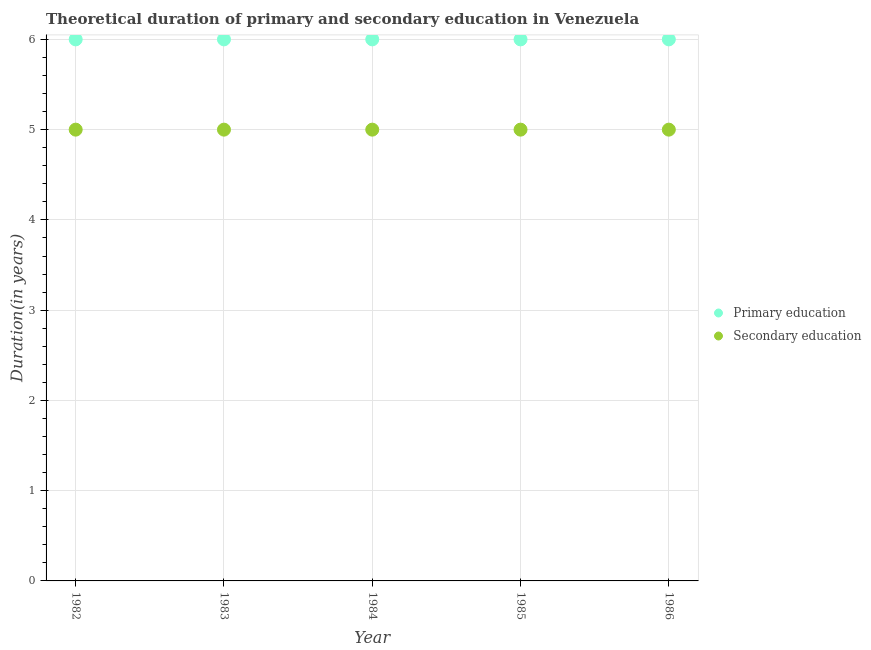How many different coloured dotlines are there?
Make the answer very short. 2. Is the number of dotlines equal to the number of legend labels?
Provide a short and direct response. Yes. Across all years, what is the minimum duration of secondary education?
Give a very brief answer. 5. What is the total duration of primary education in the graph?
Your answer should be compact. 30. What is the difference between the duration of primary education in 1983 and that in 1985?
Offer a terse response. 0. What is the difference between the duration of secondary education in 1986 and the duration of primary education in 1984?
Provide a short and direct response. -1. What is the average duration of secondary education per year?
Give a very brief answer. 5. In the year 1985, what is the difference between the duration of primary education and duration of secondary education?
Your response must be concise. 1. In how many years, is the duration of primary education greater than 3.8 years?
Your answer should be compact. 5. Is the duration of secondary education in 1983 less than that in 1984?
Offer a very short reply. No. Is the difference between the duration of primary education in 1982 and 1984 greater than the difference between the duration of secondary education in 1982 and 1984?
Offer a terse response. No. What is the difference between the highest and the second highest duration of primary education?
Provide a short and direct response. 0. In how many years, is the duration of primary education greater than the average duration of primary education taken over all years?
Offer a terse response. 0. Is the sum of the duration of primary education in 1984 and 1986 greater than the maximum duration of secondary education across all years?
Ensure brevity in your answer.  Yes. Does the duration of secondary education monotonically increase over the years?
Provide a succinct answer. No. How many dotlines are there?
Make the answer very short. 2. How many years are there in the graph?
Provide a succinct answer. 5. What is the difference between two consecutive major ticks on the Y-axis?
Provide a short and direct response. 1. Does the graph contain any zero values?
Make the answer very short. No. How are the legend labels stacked?
Ensure brevity in your answer.  Vertical. What is the title of the graph?
Ensure brevity in your answer.  Theoretical duration of primary and secondary education in Venezuela. What is the label or title of the Y-axis?
Make the answer very short. Duration(in years). What is the Duration(in years) of Secondary education in 1982?
Provide a succinct answer. 5. What is the Duration(in years) of Primary education in 1984?
Offer a very short reply. 6. What is the Duration(in years) in Primary education in 1985?
Your response must be concise. 6. What is the Duration(in years) of Secondary education in 1985?
Keep it short and to the point. 5. What is the Duration(in years) of Secondary education in 1986?
Make the answer very short. 5. Across all years, what is the maximum Duration(in years) of Primary education?
Your answer should be compact. 6. Across all years, what is the maximum Duration(in years) of Secondary education?
Provide a short and direct response. 5. Across all years, what is the minimum Duration(in years) of Secondary education?
Offer a terse response. 5. What is the difference between the Duration(in years) in Primary education in 1982 and that in 1983?
Your answer should be very brief. 0. What is the difference between the Duration(in years) in Secondary education in 1982 and that in 1984?
Your answer should be very brief. 0. What is the difference between the Duration(in years) of Primary education in 1982 and that in 1985?
Make the answer very short. 0. What is the difference between the Duration(in years) in Secondary education in 1982 and that in 1985?
Your response must be concise. 0. What is the difference between the Duration(in years) of Primary education in 1982 and that in 1986?
Your answer should be compact. 0. What is the difference between the Duration(in years) of Secondary education in 1982 and that in 1986?
Your answer should be very brief. 0. What is the difference between the Duration(in years) of Primary education in 1984 and that in 1985?
Ensure brevity in your answer.  0. What is the difference between the Duration(in years) in Primary education in 1984 and that in 1986?
Your answer should be compact. 0. What is the difference between the Duration(in years) in Secondary education in 1985 and that in 1986?
Ensure brevity in your answer.  0. What is the difference between the Duration(in years) of Primary education in 1982 and the Duration(in years) of Secondary education in 1983?
Make the answer very short. 1. What is the difference between the Duration(in years) of Primary education in 1982 and the Duration(in years) of Secondary education in 1985?
Provide a short and direct response. 1. What is the difference between the Duration(in years) of Primary education in 1983 and the Duration(in years) of Secondary education in 1985?
Offer a very short reply. 1. What is the difference between the Duration(in years) of Primary education in 1985 and the Duration(in years) of Secondary education in 1986?
Provide a succinct answer. 1. What is the average Duration(in years) in Secondary education per year?
Your answer should be very brief. 5. In the year 1982, what is the difference between the Duration(in years) of Primary education and Duration(in years) of Secondary education?
Make the answer very short. 1. In the year 1983, what is the difference between the Duration(in years) of Primary education and Duration(in years) of Secondary education?
Your answer should be very brief. 1. In the year 1986, what is the difference between the Duration(in years) of Primary education and Duration(in years) of Secondary education?
Your answer should be compact. 1. What is the ratio of the Duration(in years) of Primary education in 1982 to that in 1983?
Keep it short and to the point. 1. What is the ratio of the Duration(in years) in Secondary education in 1982 to that in 1984?
Your response must be concise. 1. What is the ratio of the Duration(in years) in Primary education in 1982 to that in 1985?
Keep it short and to the point. 1. What is the ratio of the Duration(in years) in Primary education in 1982 to that in 1986?
Keep it short and to the point. 1. What is the ratio of the Duration(in years) in Primary education in 1983 to that in 1984?
Give a very brief answer. 1. What is the ratio of the Duration(in years) of Primary education in 1983 to that in 1985?
Your answer should be compact. 1. What is the ratio of the Duration(in years) in Secondary education in 1983 to that in 1985?
Your answer should be compact. 1. What is the ratio of the Duration(in years) in Primary education in 1983 to that in 1986?
Keep it short and to the point. 1. What is the ratio of the Duration(in years) of Secondary education in 1984 to that in 1986?
Make the answer very short. 1. What is the ratio of the Duration(in years) of Primary education in 1985 to that in 1986?
Offer a terse response. 1. What is the ratio of the Duration(in years) of Secondary education in 1985 to that in 1986?
Make the answer very short. 1. What is the difference between the highest and the second highest Duration(in years) of Primary education?
Your answer should be compact. 0. What is the difference between the highest and the second highest Duration(in years) in Secondary education?
Keep it short and to the point. 0. What is the difference between the highest and the lowest Duration(in years) in Primary education?
Your answer should be very brief. 0. What is the difference between the highest and the lowest Duration(in years) in Secondary education?
Keep it short and to the point. 0. 